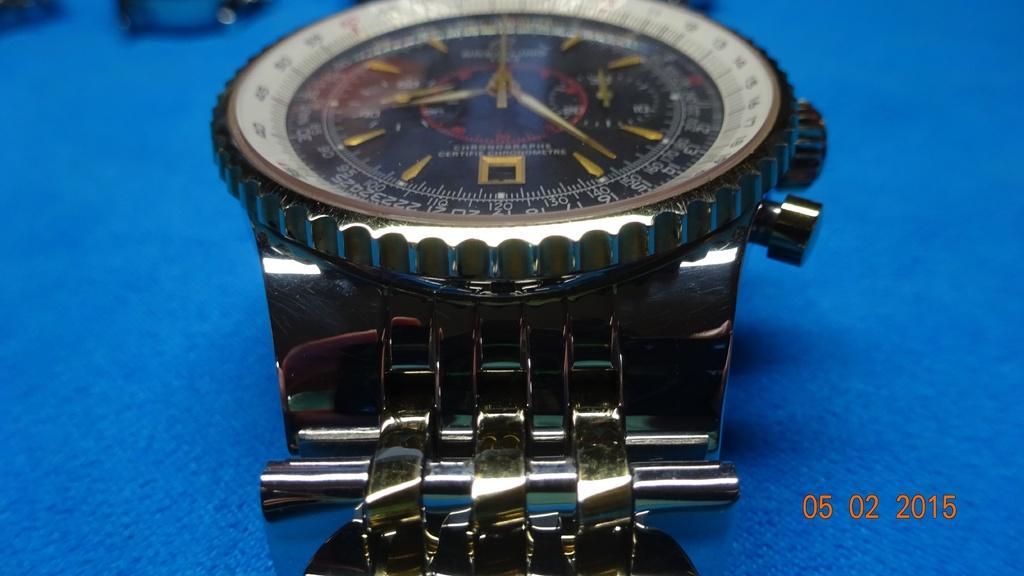How would you summarize this image in a sentence or two? This image consists of a wristwatch kept on a table. The table is covered with a blue cloth. The watch is made up of metal. 